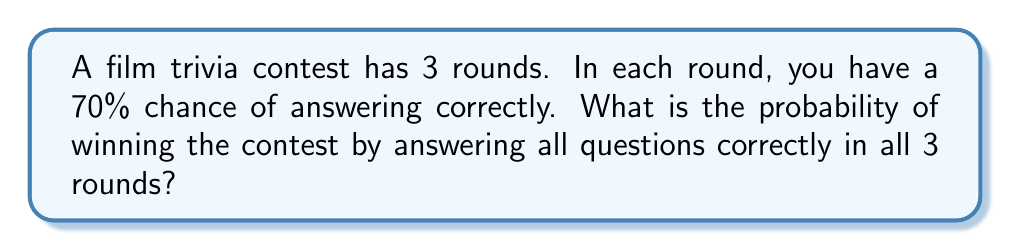Help me with this question. Let's approach this step-by-step:

1) For each round, the probability of answering correctly is 70% or 0.7.

2) To win the contest, you need to answer correctly in all 3 rounds. This means we need to calculate the probability of three independent events all occurring.

3) When we have independent events and we want all of them to occur, we multiply their individual probabilities.

4) So, the probability of winning is:

   $P(\text{winning}) = P(\text{round 1 correct}) \times P(\text{round 2 correct}) \times P(\text{round 3 correct})$

5) Substituting the values:

   $P(\text{winning}) = 0.7 \times 0.7 \times 0.7$

6) Calculating:

   $P(\text{winning}) = 0.7^3 = 0.343$

7) Converting to a percentage:

   $0.343 \times 100\% = 34.3\%$

Therefore, the probability of winning the contest by answering all questions correctly in all 3 rounds is approximately 34.3%.
Answer: 34.3% 